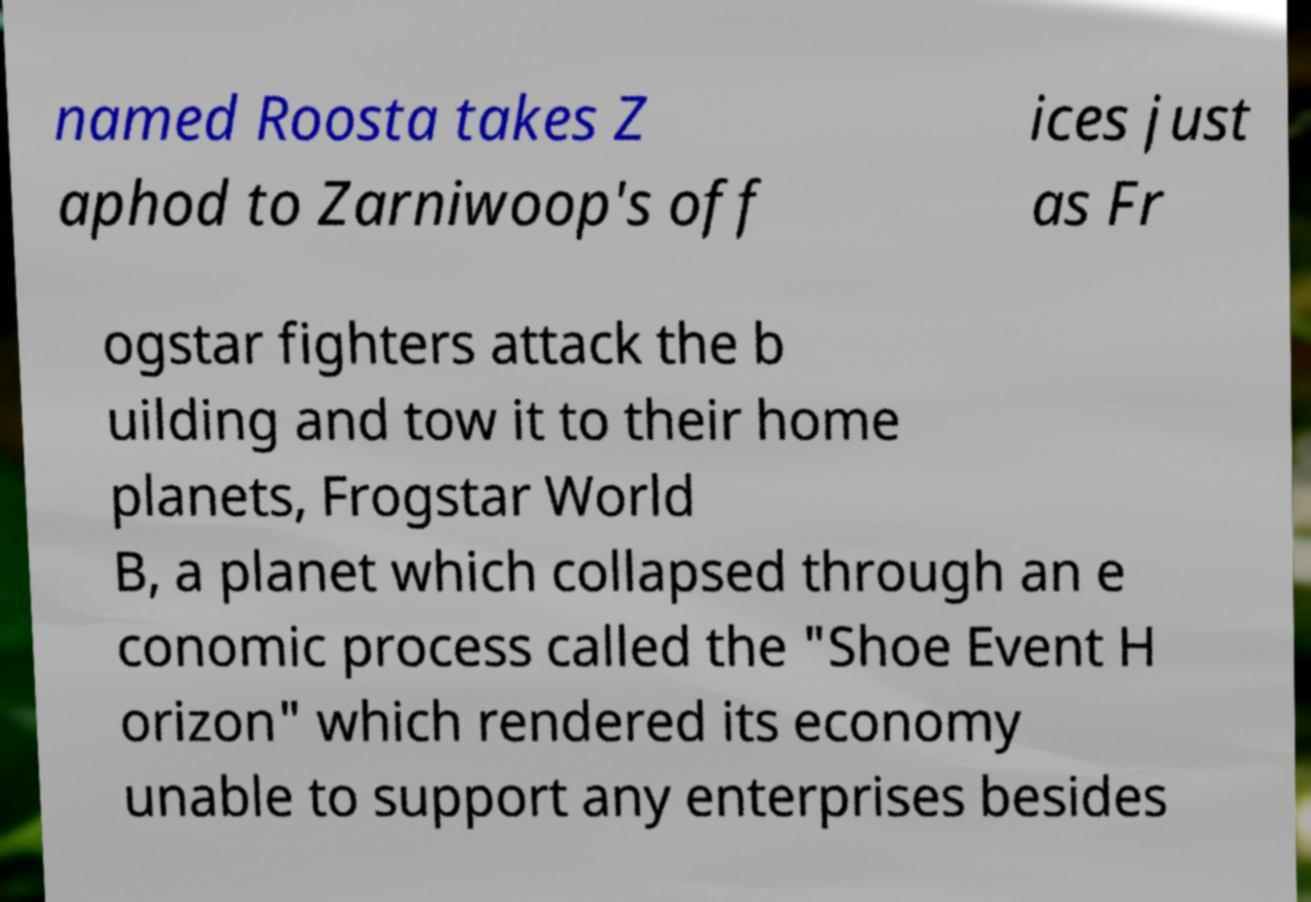Could you assist in decoding the text presented in this image and type it out clearly? named Roosta takes Z aphod to Zarniwoop's off ices just as Fr ogstar fighters attack the b uilding and tow it to their home planets, Frogstar World B, a planet which collapsed through an e conomic process called the "Shoe Event H orizon" which rendered its economy unable to support any enterprises besides 